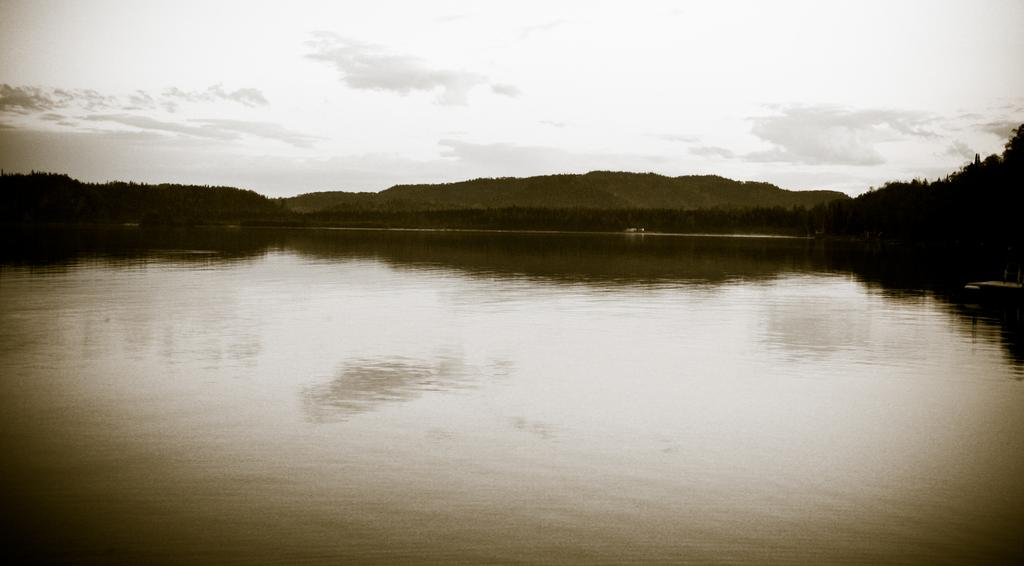What is the main feature of the image? There is water in a lake in the image. What can be seen behind the lake? There are trees and mountains behind the lake in the image. How many dimes can be seen floating on the surface of the lake in the image? There are no dimes visible in the image; it only features a lake with water, trees, and mountains. 